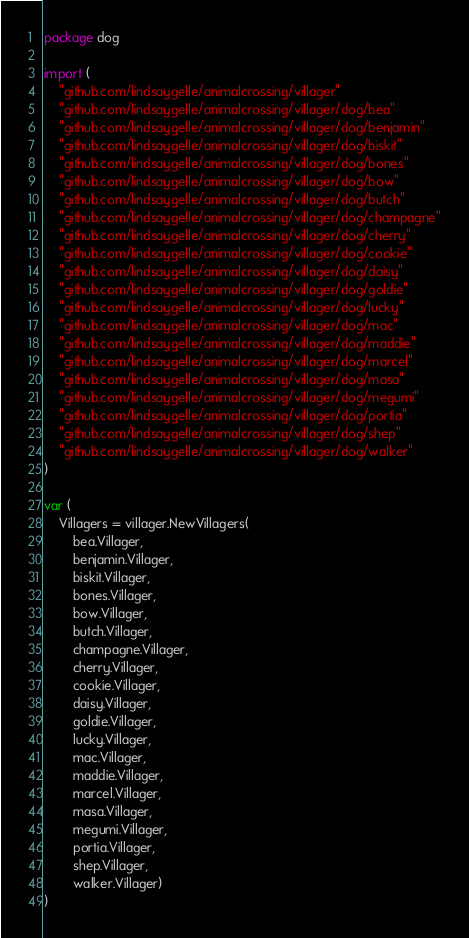Convert code to text. <code><loc_0><loc_0><loc_500><loc_500><_Go_>package dog

import (
	"github.com/lindsaygelle/animalcrossing/villager"
	"github.com/lindsaygelle/animalcrossing/villager/dog/bea"
	"github.com/lindsaygelle/animalcrossing/villager/dog/benjamin"
	"github.com/lindsaygelle/animalcrossing/villager/dog/biskit"
	"github.com/lindsaygelle/animalcrossing/villager/dog/bones"
	"github.com/lindsaygelle/animalcrossing/villager/dog/bow"
	"github.com/lindsaygelle/animalcrossing/villager/dog/butch"
	"github.com/lindsaygelle/animalcrossing/villager/dog/champagne"
	"github.com/lindsaygelle/animalcrossing/villager/dog/cherry"
	"github.com/lindsaygelle/animalcrossing/villager/dog/cookie"
	"github.com/lindsaygelle/animalcrossing/villager/dog/daisy"
	"github.com/lindsaygelle/animalcrossing/villager/dog/goldie"
	"github.com/lindsaygelle/animalcrossing/villager/dog/lucky"
	"github.com/lindsaygelle/animalcrossing/villager/dog/mac"
	"github.com/lindsaygelle/animalcrossing/villager/dog/maddie"
	"github.com/lindsaygelle/animalcrossing/villager/dog/marcel"
	"github.com/lindsaygelle/animalcrossing/villager/dog/masa"
	"github.com/lindsaygelle/animalcrossing/villager/dog/megumi"
	"github.com/lindsaygelle/animalcrossing/villager/dog/portia"
	"github.com/lindsaygelle/animalcrossing/villager/dog/shep"
	"github.com/lindsaygelle/animalcrossing/villager/dog/walker"
)

var (
	Villagers = villager.NewVillagers(
		bea.Villager,
		benjamin.Villager,
		biskit.Villager,
		bones.Villager,
		bow.Villager,
		butch.Villager,
		champagne.Villager,
		cherry.Villager,
		cookie.Villager,
		daisy.Villager,
		goldie.Villager,
		lucky.Villager,
		mac.Villager,
		maddie.Villager,
		marcel.Villager,
		masa.Villager,
		megumi.Villager,
		portia.Villager,
		shep.Villager,
		walker.Villager)
)
</code> 